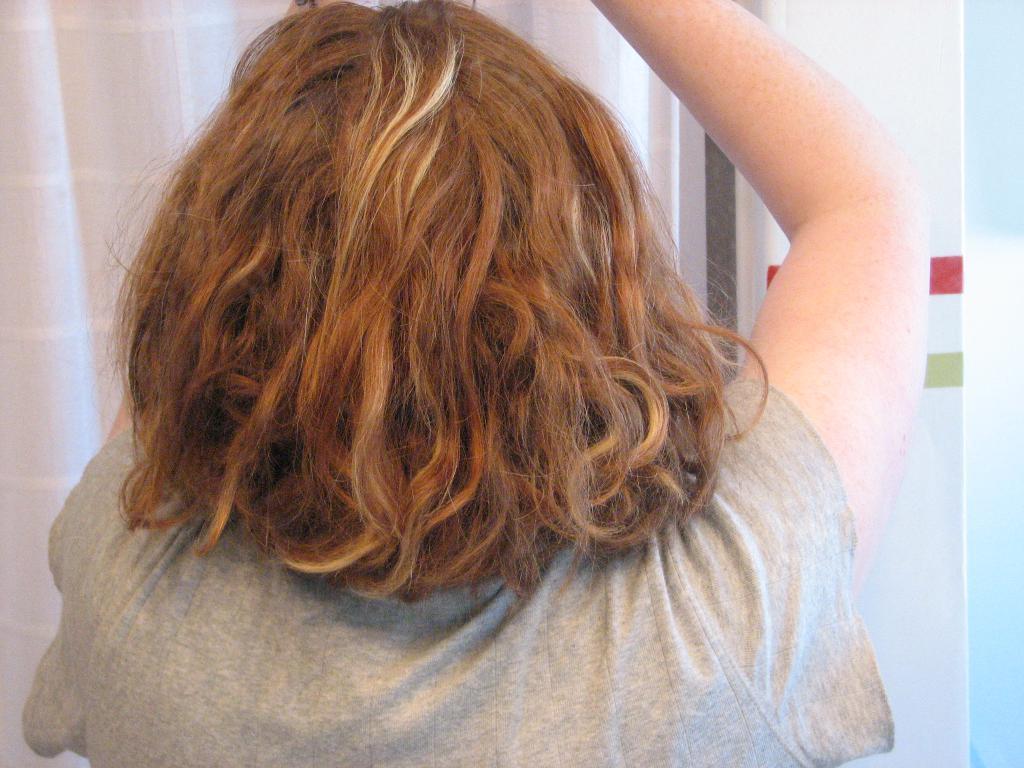How would you summarize this image in a sentence or two? In the image we can see a person. Behind the person there is a curtain. 